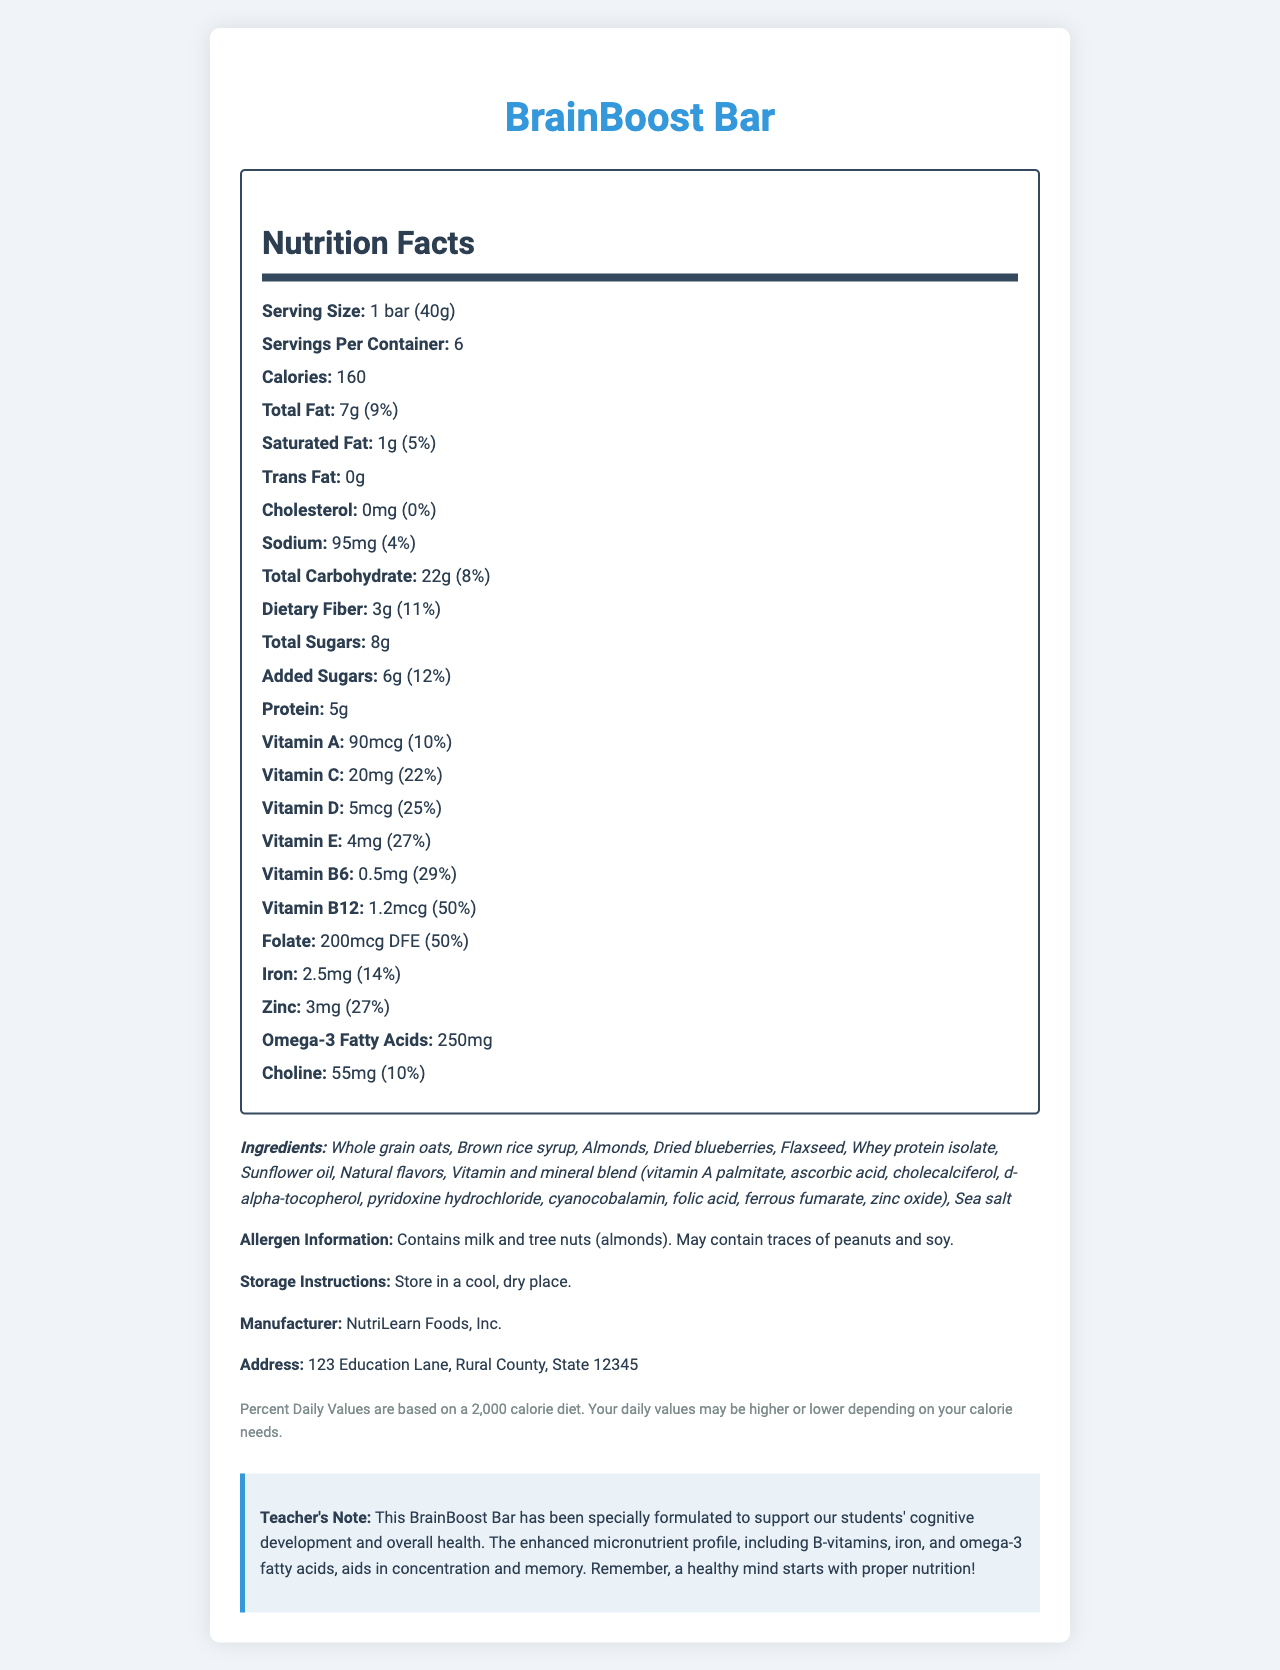what is the serving size of the BrainBoost Bar? The document specifies the serving size as "1 bar (40g)."
Answer: 1 bar (40g) how many vitamins are listed in the Nutrition Facts? The vitamins listed are Vitamin A, C, D, E, B6, B12, and Folate.
Answer: Seven how much protein does the BrainBoost Bar contain per serving? The protein content is listed as "5g."
Answer: 5g what is the daily value percentage for vitamin B12? The document indicates that Vitamin B12 has a daily value percentage of 50%.
Answer: 50% what is the calorie count for one BrainBoost Bar? The document lists "Calories: 160."
Answer: 160 which of these ingredients is not present in the BrainBoost Bar? A. Whey protein isolate B. Almonds C. Honey D. Dried blueberries Honey is not listed among the ingredients in the document.
Answer: C what is the daily value percentage for dietary fiber? A. 8% B. 9% C. 10% D. 11% The daily value percentage for dietary fiber is listed as "11%."
Answer: D does the product contain any trans fat? The document clarifies that there are "0g" of trans fat.
Answer: No is this product suitable for someone with a tree nut allergy? The document states that the product contains tree nuts (almonds).
Answer: No summarize the main details of the Nutrition Facts Label on the BrainBoost Bar. The summary includes key nutritional details, the enhanced micronutrient profile, and additional relevant information such as ingredients and allergen warnings.
Answer: The BrainBoost Bar is a snack bar designed to support cognitive development. Each serving size is 1 bar (40g), with 160 calories per serving. It contains 7g of total fat, 3g of dietary fiber, 8g of total sugars (6g added), and 5g of protein. The bar is fortified with several vitamins and minerals, including significant amounts of Vitamin B12, Folate, Vitamin E, and Vitamin B6. The document also lists ingredients, allergen information, and storage instructions. what company manufactures the BrainBoost Bar? The document mentions that the manufacturer is "NutriLearn Foods, Inc."
Answer: NutriLearn Foods, Inc. how many servings are in one container of BrainBoost Bars? The document specifies that there are "6 servings per container."
Answer: 6 what is the storage instruction for the BrainBoost Bar? The document provides the storage instruction as "Store in a cool, dry place."
Answer: Store in a cool, dry place. what is the exact address of the manufacturer? The document lists the address as "123 Education Lane, Rural County, State 12345."
Answer: 123 Education Lane, Rural County, State 12345 list all allergens identified in the product. The document identifies the allergens as "Contains milk and tree nuts (almonds). May contain traces of peanuts and soy."
Answer: Milk, tree nuts (almonds), may contain traces of peanuts and soy. are the percent daily values based on a specific calorie diet? The document states, "Percent Daily Values are based on a 2,000 calorie diet."
Answer: Yes how much choline is in one serving, and what is its daily value percentage? The document lists "Choline: 55mg (10%)."
Answer: 55mg, 10% what benefits are highlighted by the teacher's note regarding the BrainBoost Bar? The teacher's note emphasizes that the enhanced micronutrient profile aids in cognitive development, concentration, and memory.
Answer: Cognitive development, concentration, and memory who is the target consumer audience for the BrainBoost Bar? The teacher's note implies that the target audience is students, specifically those aimed at improving cognitive development.
Answer: Students does the document indicate the origin of the ingredients? The document does not provide any information regarding the origin of the ingredients.
Answer: Cannot be determined 